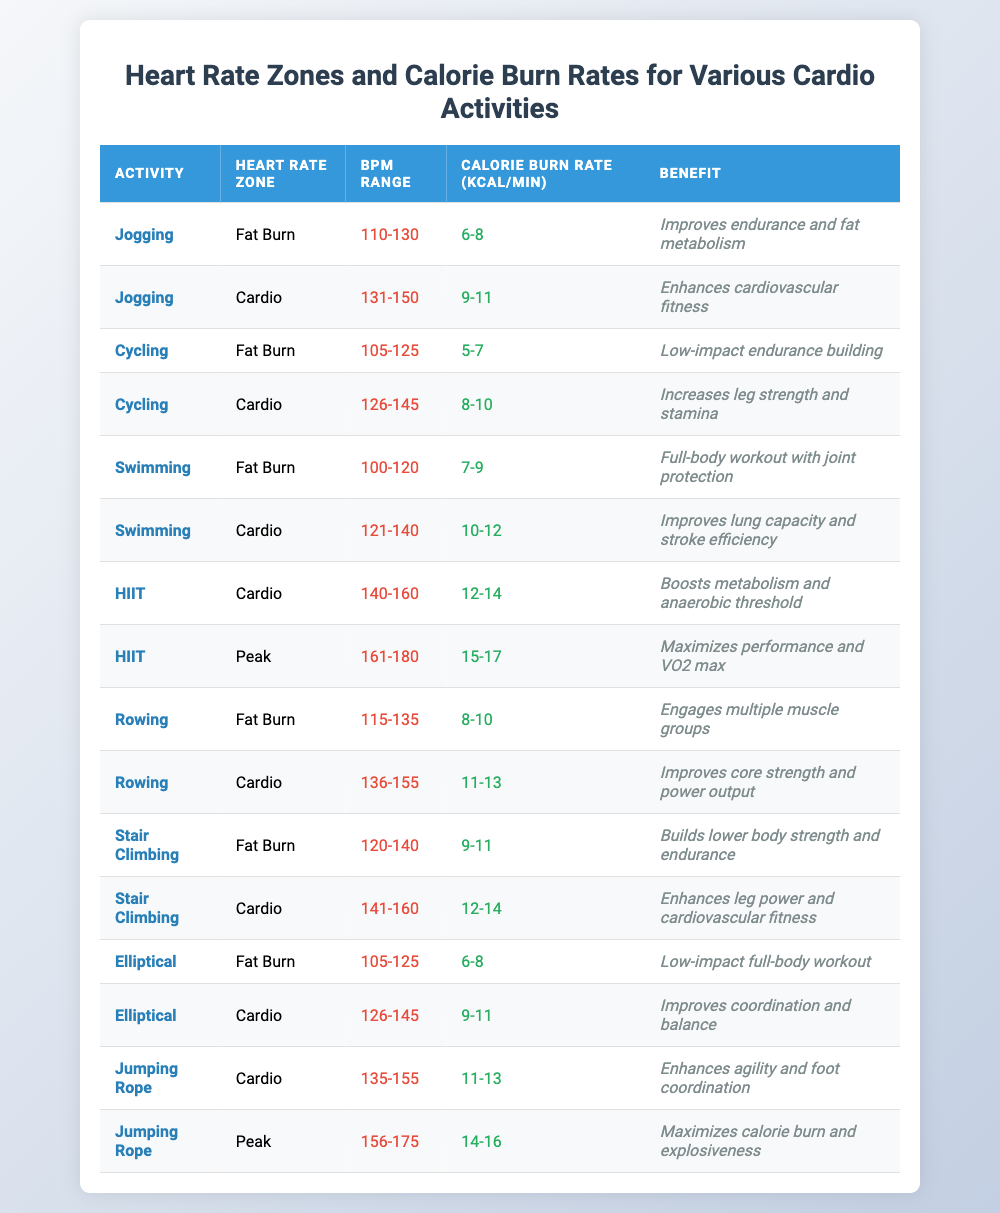What is the calorie burn rate range for jogging in the fat burn zone? According to the table, the calorie burn rate for jogging in the fat burn zone is listed as 6-8 kcal/min.
Answer: 6-8 kcal/min Which activity has the highest calorie burn rate in the peak heart rate zone? The HIIT activity has a calorie burn rate of 15-17 kcal/min in the peak heart rate zone, which is the highest among all activities.
Answer: HIIT Are there any activities listed that have a calorie burn rate of 10-12 kcal/min? The table shows that both swimming in the cardio zone and HIIT in the cardio zone have a calorie burn rate of 10-12 kcal/min.
Answer: Yes What is the difference in calorie burn rates between rowing in the cardio zone and jumping rope in the cardio zone? Rowing in the cardio zone has a burn rate of 11-13 kcal/min, while jumping rope in the cardio zone has a rate of 11-13 kcal/min. Thus, the difference is 0 kcal/min.
Answer: 0 kcal/min Which activity combines fat burn and aerobic benefits and has the lowest heart rate zone BPM range? Cycling in the fat burn zone has the BPM range of 105-125, which is the lowest among the activities listed for fat burn benefits.
Answer: Cycling What is the average BPM range for the cardio heart rate zone across all activities listed? The BPM ranges for the cardio zone are 131-150 for jogging, 126-145 for cycling, 121-140 for swimming, 140-160 for HIIT, 136-155 for rowing, 126-145 for elliptical, and 135-155 for jumping rope. Summing these gives 131 + 150 + 126 + 140 + 136 + 145 + 135 = 1,013. There are 7 activities, so the average range is (1,013/7) = 144.71, which we can round and say is roughly 145 bpm.
Answer: 145 bpm Which cardio activity has the closest BPM range to the fat burn zone for swimming? Swimming’s fat burn zone has a BPM range of 100-120, and the closest cardio activity by BPM range is cycling in the fat burn zone with a range of 105-125. The upper limit of cycling overlaps into swimming's fat burn zone.
Answer: Cycling Is there any activity shown in the table that does not provide a benefit to cardiovascular fitness? The table lists all activities with benefits. The lowest impact activity, cycling in the fat burn zone, emphasizes low-impact endurance building, which indirectly supports cardiovascular fitness. Therefore, all activities listed provide some cardiovascular benefit.
Answer: No 